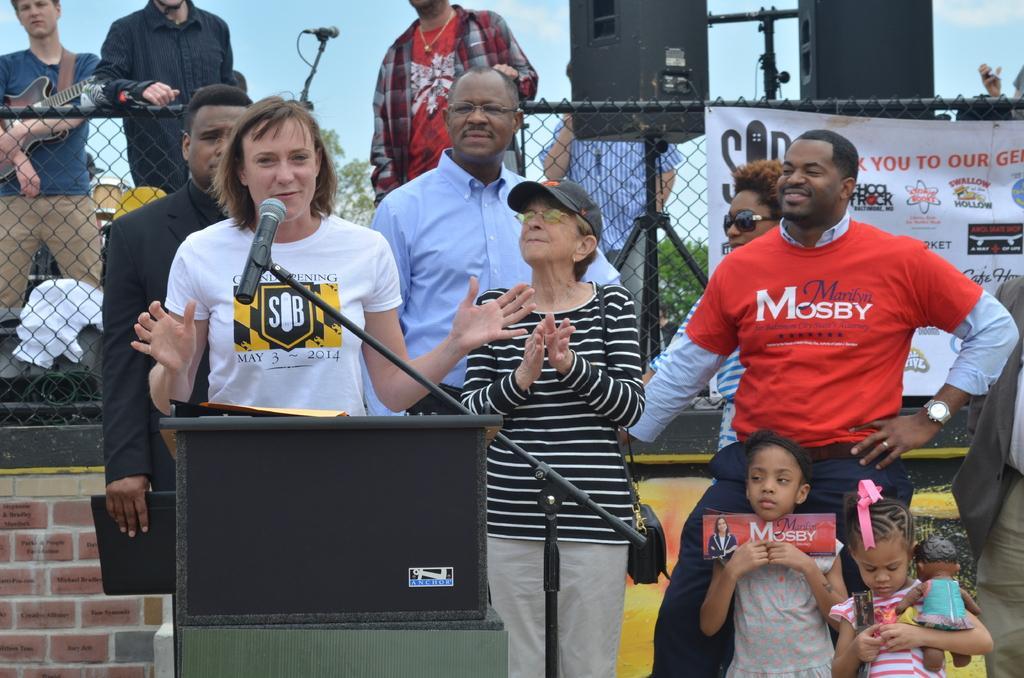Please provide a concise description of this image. Here I can see few people are standing. On the left side there is a person standing in front of the podium and speaking on the mike. Other people are looking at this person. In the background there is a net fencing to which a banner is attached. Behind the fencing there are two speakers and few people are standing. At the top of the image I can see the sky. At the bottom right there are two children holding toys in the hands and standing. 